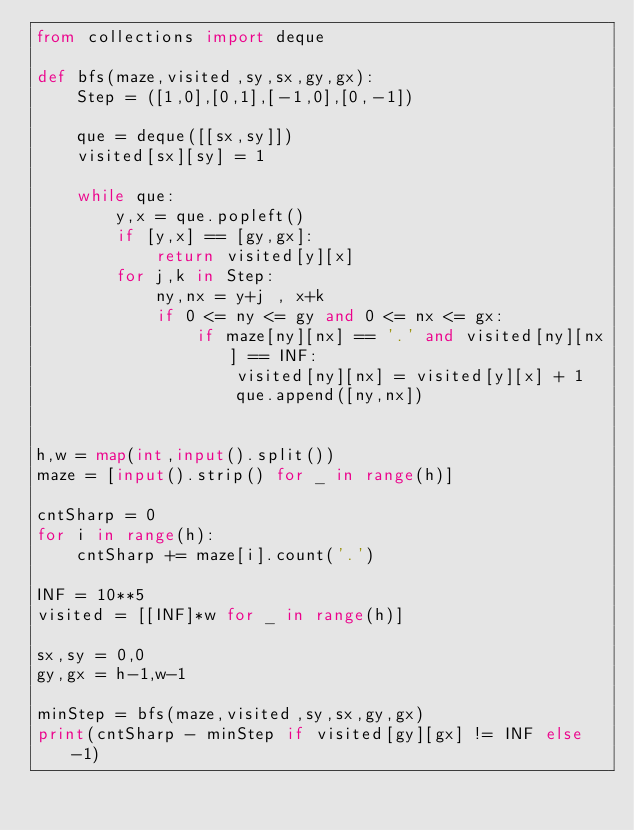Convert code to text. <code><loc_0><loc_0><loc_500><loc_500><_Python_>from collections import deque

def bfs(maze,visited,sy,sx,gy,gx):
    Step = ([1,0],[0,1],[-1,0],[0,-1])
    
    que = deque([[sx,sy]])
    visited[sx][sy] = 1
    
    while que:
        y,x = que.popleft()
        if [y,x] == [gy,gx]:
            return visited[y][x]
        for j,k in Step:
            ny,nx = y+j , x+k
            if 0 <= ny <= gy and 0 <= nx <= gx:
                if maze[ny][nx] == '.' and visited[ny][nx] == INF:
                    visited[ny][nx] = visited[y][x] + 1
                    que.append([ny,nx])


h,w = map(int,input().split())
maze = [input().strip() for _ in range(h)]

cntSharp = 0
for i in range(h):
    cntSharp += maze[i].count('.')

INF = 10**5
visited = [[INF]*w for _ in range(h)]

sx,sy = 0,0
gy,gx = h-1,w-1

minStep = bfs(maze,visited,sy,sx,gy,gx)
print(cntSharp - minStep if visited[gy][gx] != INF else -1)</code> 